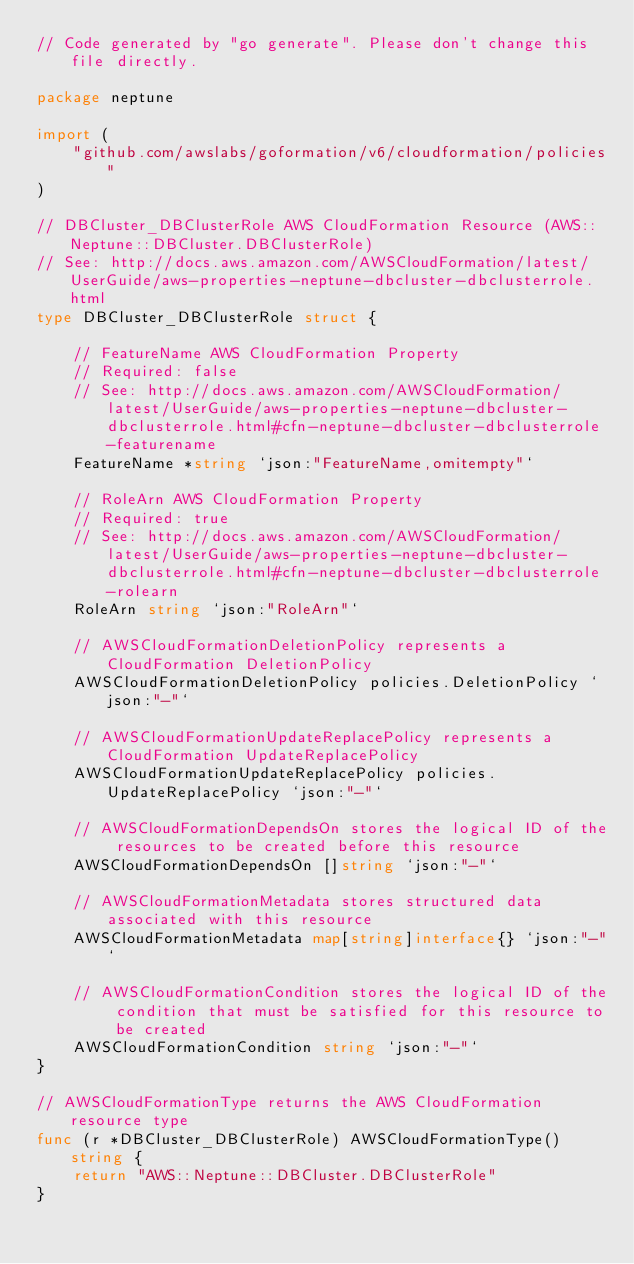Convert code to text. <code><loc_0><loc_0><loc_500><loc_500><_Go_>// Code generated by "go generate". Please don't change this file directly.

package neptune

import (
	"github.com/awslabs/goformation/v6/cloudformation/policies"
)

// DBCluster_DBClusterRole AWS CloudFormation Resource (AWS::Neptune::DBCluster.DBClusterRole)
// See: http://docs.aws.amazon.com/AWSCloudFormation/latest/UserGuide/aws-properties-neptune-dbcluster-dbclusterrole.html
type DBCluster_DBClusterRole struct {

	// FeatureName AWS CloudFormation Property
	// Required: false
	// See: http://docs.aws.amazon.com/AWSCloudFormation/latest/UserGuide/aws-properties-neptune-dbcluster-dbclusterrole.html#cfn-neptune-dbcluster-dbclusterrole-featurename
	FeatureName *string `json:"FeatureName,omitempty"`

	// RoleArn AWS CloudFormation Property
	// Required: true
	// See: http://docs.aws.amazon.com/AWSCloudFormation/latest/UserGuide/aws-properties-neptune-dbcluster-dbclusterrole.html#cfn-neptune-dbcluster-dbclusterrole-rolearn
	RoleArn string `json:"RoleArn"`

	// AWSCloudFormationDeletionPolicy represents a CloudFormation DeletionPolicy
	AWSCloudFormationDeletionPolicy policies.DeletionPolicy `json:"-"`

	// AWSCloudFormationUpdateReplacePolicy represents a CloudFormation UpdateReplacePolicy
	AWSCloudFormationUpdateReplacePolicy policies.UpdateReplacePolicy `json:"-"`

	// AWSCloudFormationDependsOn stores the logical ID of the resources to be created before this resource
	AWSCloudFormationDependsOn []string `json:"-"`

	// AWSCloudFormationMetadata stores structured data associated with this resource
	AWSCloudFormationMetadata map[string]interface{} `json:"-"`

	// AWSCloudFormationCondition stores the logical ID of the condition that must be satisfied for this resource to be created
	AWSCloudFormationCondition string `json:"-"`
}

// AWSCloudFormationType returns the AWS CloudFormation resource type
func (r *DBCluster_DBClusterRole) AWSCloudFormationType() string {
	return "AWS::Neptune::DBCluster.DBClusterRole"
}
</code> 